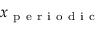Convert formula to latex. <formula><loc_0><loc_0><loc_500><loc_500>x _ { p e r i o d i c }</formula> 